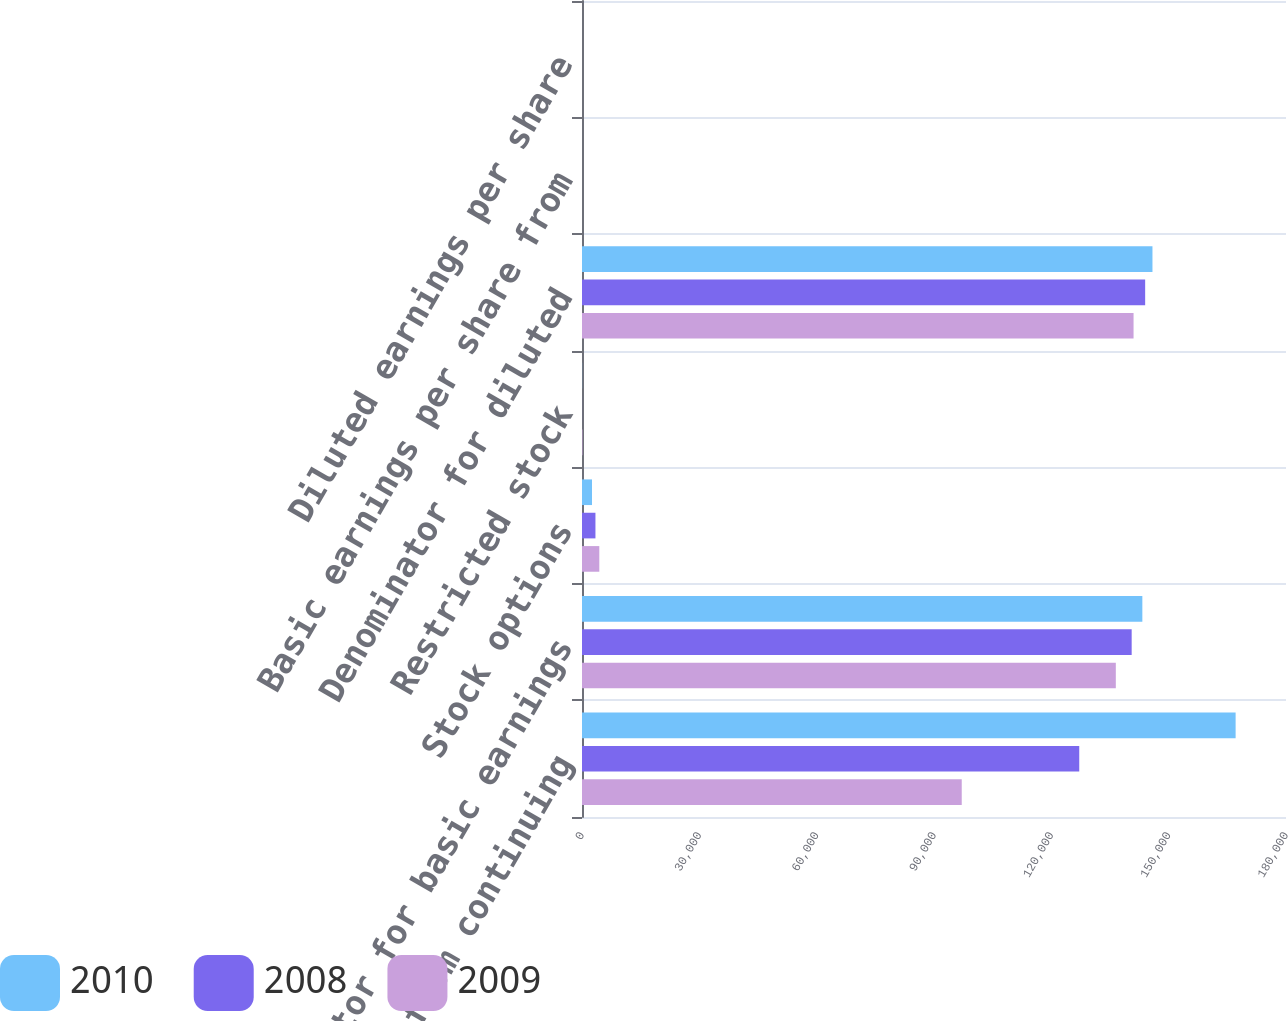<chart> <loc_0><loc_0><loc_500><loc_500><stacked_bar_chart><ecel><fcel>Income from continuing<fcel>Denominator for basic earnings<fcel>Stock options<fcel>Restricted stock<fcel>Denominator for diluted<fcel>Basic earnings per share from<fcel>Diluted earnings per share<nl><fcel>2010<fcel>167118<fcel>143271<fcel>2559<fcel>27<fcel>145857<fcel>1.17<fcel>1.15<nl><fcel>2008<fcel>127137<fcel>140541<fcel>3438<fcel>11<fcel>143990<fcel>0.9<fcel>0.88<nl><fcel>2009<fcel>97092<fcel>136488<fcel>4426<fcel>109<fcel>141023<fcel>0.71<fcel>0.69<nl></chart> 